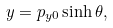Convert formula to latex. <formula><loc_0><loc_0><loc_500><loc_500>y = p _ { y 0 } \sinh \theta ,</formula> 